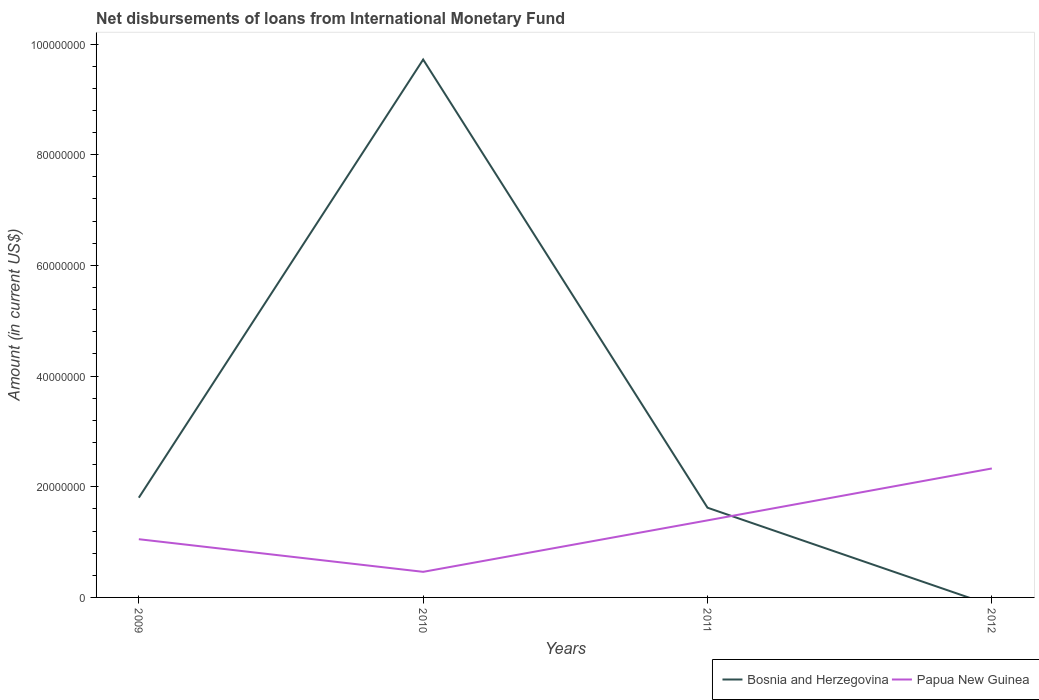Does the line corresponding to Bosnia and Herzegovina intersect with the line corresponding to Papua New Guinea?
Ensure brevity in your answer.  Yes. Across all years, what is the maximum amount of loans disbursed in Bosnia and Herzegovina?
Your response must be concise. 0. What is the total amount of loans disbursed in Papua New Guinea in the graph?
Your answer should be compact. -9.38e+06. What is the difference between the highest and the second highest amount of loans disbursed in Papua New Guinea?
Make the answer very short. 1.87e+07. What is the difference between the highest and the lowest amount of loans disbursed in Bosnia and Herzegovina?
Ensure brevity in your answer.  1. How many lines are there?
Give a very brief answer. 2. How many years are there in the graph?
Make the answer very short. 4. What is the difference between two consecutive major ticks on the Y-axis?
Make the answer very short. 2.00e+07. Are the values on the major ticks of Y-axis written in scientific E-notation?
Give a very brief answer. No. Does the graph contain any zero values?
Keep it short and to the point. Yes. Where does the legend appear in the graph?
Provide a succinct answer. Bottom right. How many legend labels are there?
Keep it short and to the point. 2. What is the title of the graph?
Your answer should be very brief. Net disbursements of loans from International Monetary Fund. What is the Amount (in current US$) in Bosnia and Herzegovina in 2009?
Provide a short and direct response. 1.80e+07. What is the Amount (in current US$) in Papua New Guinea in 2009?
Make the answer very short. 1.05e+07. What is the Amount (in current US$) in Bosnia and Herzegovina in 2010?
Your answer should be very brief. 9.72e+07. What is the Amount (in current US$) in Papua New Guinea in 2010?
Offer a very short reply. 4.62e+06. What is the Amount (in current US$) in Bosnia and Herzegovina in 2011?
Give a very brief answer. 1.62e+07. What is the Amount (in current US$) of Papua New Guinea in 2011?
Make the answer very short. 1.39e+07. What is the Amount (in current US$) in Papua New Guinea in 2012?
Offer a very short reply. 2.33e+07. Across all years, what is the maximum Amount (in current US$) in Bosnia and Herzegovina?
Give a very brief answer. 9.72e+07. Across all years, what is the maximum Amount (in current US$) of Papua New Guinea?
Your answer should be compact. 2.33e+07. Across all years, what is the minimum Amount (in current US$) in Papua New Guinea?
Your response must be concise. 4.62e+06. What is the total Amount (in current US$) in Bosnia and Herzegovina in the graph?
Your answer should be very brief. 1.31e+08. What is the total Amount (in current US$) in Papua New Guinea in the graph?
Offer a very short reply. 5.24e+07. What is the difference between the Amount (in current US$) of Bosnia and Herzegovina in 2009 and that in 2010?
Your response must be concise. -7.92e+07. What is the difference between the Amount (in current US$) in Papua New Guinea in 2009 and that in 2010?
Your response must be concise. 5.90e+06. What is the difference between the Amount (in current US$) of Bosnia and Herzegovina in 2009 and that in 2011?
Make the answer very short. 1.81e+06. What is the difference between the Amount (in current US$) in Papua New Guinea in 2009 and that in 2011?
Keep it short and to the point. -3.40e+06. What is the difference between the Amount (in current US$) in Papua New Guinea in 2009 and that in 2012?
Your answer should be compact. -1.28e+07. What is the difference between the Amount (in current US$) in Bosnia and Herzegovina in 2010 and that in 2011?
Ensure brevity in your answer.  8.10e+07. What is the difference between the Amount (in current US$) of Papua New Guinea in 2010 and that in 2011?
Your answer should be very brief. -9.30e+06. What is the difference between the Amount (in current US$) of Papua New Guinea in 2010 and that in 2012?
Your answer should be very brief. -1.87e+07. What is the difference between the Amount (in current US$) in Papua New Guinea in 2011 and that in 2012?
Offer a terse response. -9.38e+06. What is the difference between the Amount (in current US$) in Bosnia and Herzegovina in 2009 and the Amount (in current US$) in Papua New Guinea in 2010?
Make the answer very short. 1.34e+07. What is the difference between the Amount (in current US$) of Bosnia and Herzegovina in 2009 and the Amount (in current US$) of Papua New Guinea in 2011?
Offer a terse response. 4.10e+06. What is the difference between the Amount (in current US$) in Bosnia and Herzegovina in 2009 and the Amount (in current US$) in Papua New Guinea in 2012?
Offer a terse response. -5.28e+06. What is the difference between the Amount (in current US$) of Bosnia and Herzegovina in 2010 and the Amount (in current US$) of Papua New Guinea in 2011?
Ensure brevity in your answer.  8.33e+07. What is the difference between the Amount (in current US$) in Bosnia and Herzegovina in 2010 and the Amount (in current US$) in Papua New Guinea in 2012?
Provide a succinct answer. 7.39e+07. What is the difference between the Amount (in current US$) in Bosnia and Herzegovina in 2011 and the Amount (in current US$) in Papua New Guinea in 2012?
Make the answer very short. -7.09e+06. What is the average Amount (in current US$) in Bosnia and Herzegovina per year?
Provide a succinct answer. 3.29e+07. What is the average Amount (in current US$) of Papua New Guinea per year?
Provide a succinct answer. 1.31e+07. In the year 2009, what is the difference between the Amount (in current US$) of Bosnia and Herzegovina and Amount (in current US$) of Papua New Guinea?
Offer a terse response. 7.50e+06. In the year 2010, what is the difference between the Amount (in current US$) of Bosnia and Herzegovina and Amount (in current US$) of Papua New Guinea?
Make the answer very short. 9.26e+07. In the year 2011, what is the difference between the Amount (in current US$) in Bosnia and Herzegovina and Amount (in current US$) in Papua New Guinea?
Keep it short and to the point. 2.29e+06. What is the ratio of the Amount (in current US$) of Bosnia and Herzegovina in 2009 to that in 2010?
Provide a short and direct response. 0.19. What is the ratio of the Amount (in current US$) of Papua New Guinea in 2009 to that in 2010?
Keep it short and to the point. 2.28. What is the ratio of the Amount (in current US$) in Bosnia and Herzegovina in 2009 to that in 2011?
Provide a short and direct response. 1.11. What is the ratio of the Amount (in current US$) in Papua New Guinea in 2009 to that in 2011?
Provide a short and direct response. 0.76. What is the ratio of the Amount (in current US$) in Papua New Guinea in 2009 to that in 2012?
Offer a very short reply. 0.45. What is the ratio of the Amount (in current US$) in Bosnia and Herzegovina in 2010 to that in 2011?
Give a very brief answer. 6. What is the ratio of the Amount (in current US$) in Papua New Guinea in 2010 to that in 2011?
Your answer should be compact. 0.33. What is the ratio of the Amount (in current US$) of Papua New Guinea in 2010 to that in 2012?
Offer a very short reply. 0.2. What is the ratio of the Amount (in current US$) of Papua New Guinea in 2011 to that in 2012?
Provide a succinct answer. 0.6. What is the difference between the highest and the second highest Amount (in current US$) of Bosnia and Herzegovina?
Your response must be concise. 7.92e+07. What is the difference between the highest and the second highest Amount (in current US$) of Papua New Guinea?
Keep it short and to the point. 9.38e+06. What is the difference between the highest and the lowest Amount (in current US$) in Bosnia and Herzegovina?
Your response must be concise. 9.72e+07. What is the difference between the highest and the lowest Amount (in current US$) of Papua New Guinea?
Offer a very short reply. 1.87e+07. 